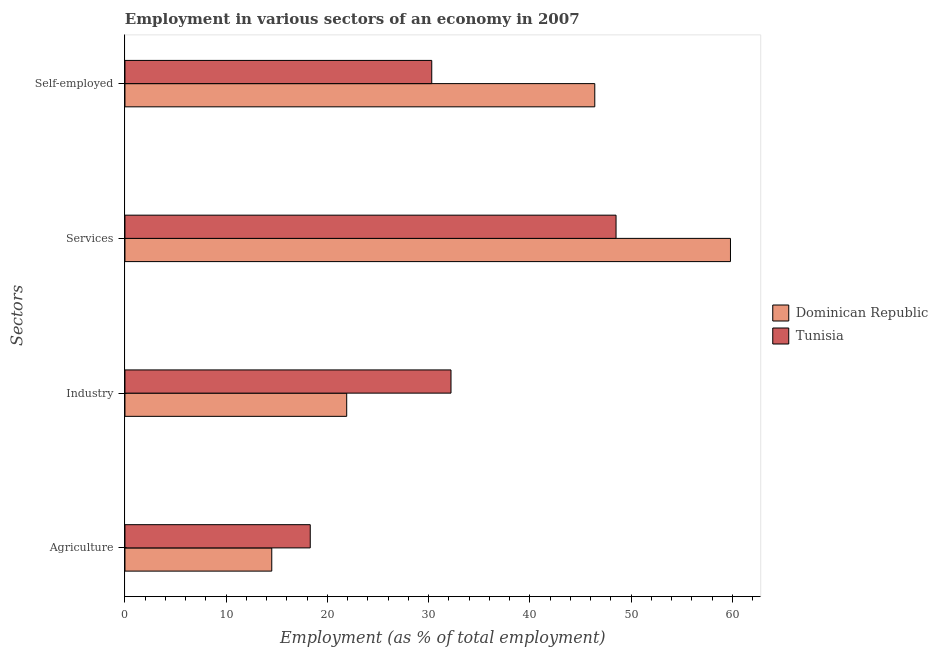How many groups of bars are there?
Offer a very short reply. 4. Are the number of bars on each tick of the Y-axis equal?
Offer a very short reply. Yes. How many bars are there on the 3rd tick from the top?
Provide a succinct answer. 2. How many bars are there on the 4th tick from the bottom?
Give a very brief answer. 2. What is the label of the 1st group of bars from the top?
Give a very brief answer. Self-employed. What is the percentage of workers in agriculture in Tunisia?
Your response must be concise. 18.3. Across all countries, what is the maximum percentage of workers in services?
Make the answer very short. 59.8. In which country was the percentage of workers in industry maximum?
Make the answer very short. Tunisia. In which country was the percentage of workers in agriculture minimum?
Provide a succinct answer. Dominican Republic. What is the total percentage of self employed workers in the graph?
Offer a terse response. 76.7. What is the difference between the percentage of workers in services in Tunisia and that in Dominican Republic?
Offer a terse response. -11.3. What is the difference between the percentage of workers in industry in Tunisia and the percentage of workers in services in Dominican Republic?
Your answer should be compact. -27.6. What is the average percentage of workers in agriculture per country?
Provide a short and direct response. 16.4. What is the difference between the percentage of workers in agriculture and percentage of self employed workers in Dominican Republic?
Provide a short and direct response. -31.9. What is the ratio of the percentage of workers in agriculture in Dominican Republic to that in Tunisia?
Your response must be concise. 0.79. Is the percentage of workers in industry in Dominican Republic less than that in Tunisia?
Provide a short and direct response. Yes. What is the difference between the highest and the second highest percentage of workers in industry?
Make the answer very short. 10.3. What is the difference between the highest and the lowest percentage of workers in industry?
Offer a very short reply. 10.3. Is the sum of the percentage of self employed workers in Tunisia and Dominican Republic greater than the maximum percentage of workers in services across all countries?
Offer a very short reply. Yes. Is it the case that in every country, the sum of the percentage of workers in agriculture and percentage of self employed workers is greater than the sum of percentage of workers in industry and percentage of workers in services?
Ensure brevity in your answer.  Yes. What does the 1st bar from the top in Industry represents?
Provide a short and direct response. Tunisia. What does the 2nd bar from the bottom in Self-employed represents?
Your answer should be very brief. Tunisia. Is it the case that in every country, the sum of the percentage of workers in agriculture and percentage of workers in industry is greater than the percentage of workers in services?
Offer a very short reply. No. How many bars are there?
Your answer should be compact. 8. Are all the bars in the graph horizontal?
Your answer should be very brief. Yes. How many countries are there in the graph?
Your response must be concise. 2. What is the difference between two consecutive major ticks on the X-axis?
Provide a short and direct response. 10. Does the graph contain any zero values?
Give a very brief answer. No. Does the graph contain grids?
Keep it short and to the point. No. Where does the legend appear in the graph?
Make the answer very short. Center right. What is the title of the graph?
Your answer should be very brief. Employment in various sectors of an economy in 2007. Does "Bermuda" appear as one of the legend labels in the graph?
Your answer should be very brief. No. What is the label or title of the X-axis?
Your answer should be very brief. Employment (as % of total employment). What is the label or title of the Y-axis?
Keep it short and to the point. Sectors. What is the Employment (as % of total employment) in Tunisia in Agriculture?
Provide a short and direct response. 18.3. What is the Employment (as % of total employment) in Dominican Republic in Industry?
Offer a very short reply. 21.9. What is the Employment (as % of total employment) of Tunisia in Industry?
Keep it short and to the point. 32.2. What is the Employment (as % of total employment) of Dominican Republic in Services?
Provide a short and direct response. 59.8. What is the Employment (as % of total employment) in Tunisia in Services?
Provide a short and direct response. 48.5. What is the Employment (as % of total employment) of Dominican Republic in Self-employed?
Your response must be concise. 46.4. What is the Employment (as % of total employment) in Tunisia in Self-employed?
Keep it short and to the point. 30.3. Across all Sectors, what is the maximum Employment (as % of total employment) in Dominican Republic?
Offer a very short reply. 59.8. Across all Sectors, what is the maximum Employment (as % of total employment) of Tunisia?
Your answer should be compact. 48.5. Across all Sectors, what is the minimum Employment (as % of total employment) in Dominican Republic?
Offer a terse response. 14.5. Across all Sectors, what is the minimum Employment (as % of total employment) in Tunisia?
Give a very brief answer. 18.3. What is the total Employment (as % of total employment) in Dominican Republic in the graph?
Give a very brief answer. 142.6. What is the total Employment (as % of total employment) in Tunisia in the graph?
Give a very brief answer. 129.3. What is the difference between the Employment (as % of total employment) in Dominican Republic in Agriculture and that in Industry?
Ensure brevity in your answer.  -7.4. What is the difference between the Employment (as % of total employment) of Dominican Republic in Agriculture and that in Services?
Your answer should be compact. -45.3. What is the difference between the Employment (as % of total employment) in Tunisia in Agriculture and that in Services?
Give a very brief answer. -30.2. What is the difference between the Employment (as % of total employment) of Dominican Republic in Agriculture and that in Self-employed?
Provide a succinct answer. -31.9. What is the difference between the Employment (as % of total employment) of Dominican Republic in Industry and that in Services?
Keep it short and to the point. -37.9. What is the difference between the Employment (as % of total employment) in Tunisia in Industry and that in Services?
Provide a short and direct response. -16.3. What is the difference between the Employment (as % of total employment) in Dominican Republic in Industry and that in Self-employed?
Your answer should be compact. -24.5. What is the difference between the Employment (as % of total employment) of Tunisia in Services and that in Self-employed?
Give a very brief answer. 18.2. What is the difference between the Employment (as % of total employment) of Dominican Republic in Agriculture and the Employment (as % of total employment) of Tunisia in Industry?
Your response must be concise. -17.7. What is the difference between the Employment (as % of total employment) in Dominican Republic in Agriculture and the Employment (as % of total employment) in Tunisia in Services?
Keep it short and to the point. -34. What is the difference between the Employment (as % of total employment) of Dominican Republic in Agriculture and the Employment (as % of total employment) of Tunisia in Self-employed?
Your answer should be very brief. -15.8. What is the difference between the Employment (as % of total employment) of Dominican Republic in Industry and the Employment (as % of total employment) of Tunisia in Services?
Keep it short and to the point. -26.6. What is the difference between the Employment (as % of total employment) of Dominican Republic in Services and the Employment (as % of total employment) of Tunisia in Self-employed?
Provide a short and direct response. 29.5. What is the average Employment (as % of total employment) in Dominican Republic per Sectors?
Ensure brevity in your answer.  35.65. What is the average Employment (as % of total employment) in Tunisia per Sectors?
Ensure brevity in your answer.  32.33. What is the difference between the Employment (as % of total employment) in Dominican Republic and Employment (as % of total employment) in Tunisia in Self-employed?
Make the answer very short. 16.1. What is the ratio of the Employment (as % of total employment) in Dominican Republic in Agriculture to that in Industry?
Your answer should be very brief. 0.66. What is the ratio of the Employment (as % of total employment) of Tunisia in Agriculture to that in Industry?
Your response must be concise. 0.57. What is the ratio of the Employment (as % of total employment) in Dominican Republic in Agriculture to that in Services?
Offer a terse response. 0.24. What is the ratio of the Employment (as % of total employment) of Tunisia in Agriculture to that in Services?
Make the answer very short. 0.38. What is the ratio of the Employment (as % of total employment) in Dominican Republic in Agriculture to that in Self-employed?
Offer a very short reply. 0.31. What is the ratio of the Employment (as % of total employment) in Tunisia in Agriculture to that in Self-employed?
Keep it short and to the point. 0.6. What is the ratio of the Employment (as % of total employment) of Dominican Republic in Industry to that in Services?
Offer a very short reply. 0.37. What is the ratio of the Employment (as % of total employment) of Tunisia in Industry to that in Services?
Provide a short and direct response. 0.66. What is the ratio of the Employment (as % of total employment) in Dominican Republic in Industry to that in Self-employed?
Ensure brevity in your answer.  0.47. What is the ratio of the Employment (as % of total employment) in Tunisia in Industry to that in Self-employed?
Provide a short and direct response. 1.06. What is the ratio of the Employment (as % of total employment) in Dominican Republic in Services to that in Self-employed?
Ensure brevity in your answer.  1.29. What is the ratio of the Employment (as % of total employment) in Tunisia in Services to that in Self-employed?
Your answer should be very brief. 1.6. What is the difference between the highest and the second highest Employment (as % of total employment) in Dominican Republic?
Ensure brevity in your answer.  13.4. What is the difference between the highest and the lowest Employment (as % of total employment) in Dominican Republic?
Give a very brief answer. 45.3. What is the difference between the highest and the lowest Employment (as % of total employment) in Tunisia?
Your answer should be very brief. 30.2. 